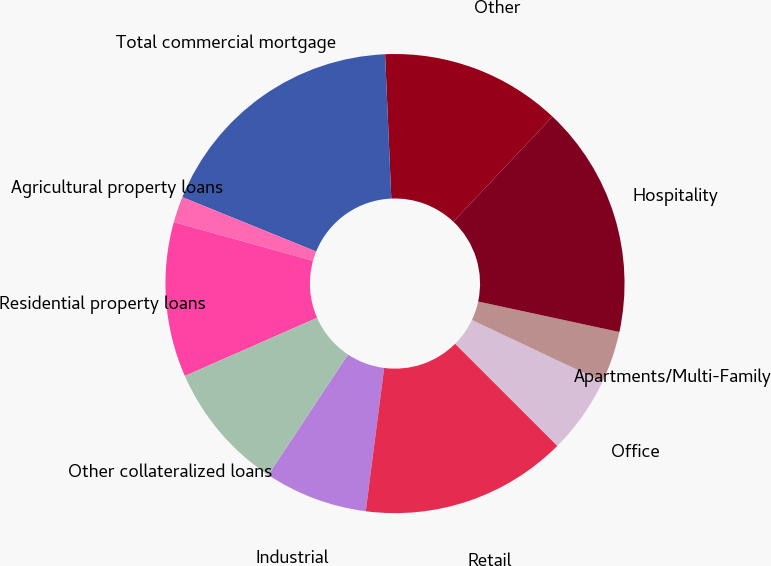<chart> <loc_0><loc_0><loc_500><loc_500><pie_chart><fcel>Industrial<fcel>Retail<fcel>Office<fcel>Apartments/Multi-Family<fcel>Hospitality<fcel>Other<fcel>Total commercial mortgage<fcel>Agricultural property loans<fcel>Residential property loans<fcel>Other collateralized loans<nl><fcel>7.28%<fcel>14.54%<fcel>5.46%<fcel>3.65%<fcel>16.35%<fcel>12.72%<fcel>18.17%<fcel>1.83%<fcel>10.91%<fcel>9.09%<nl></chart> 